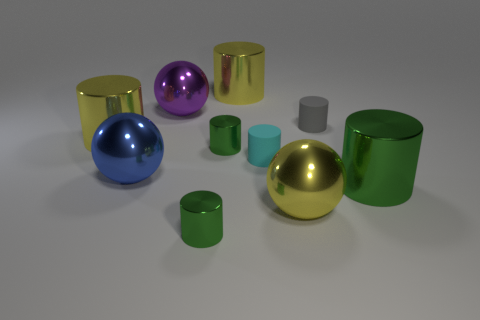Subtract all gray balls. Subtract all purple blocks. How many balls are left? 3 Subtract all purple blocks. How many cyan spheres are left? 0 Add 8 small greens. How many large yellows exist? 0 Subtract all large yellow metal spheres. Subtract all purple things. How many objects are left? 8 Add 4 big yellow metallic balls. How many big yellow metallic balls are left? 5 Add 6 blue cylinders. How many blue cylinders exist? 6 Subtract all yellow cylinders. How many cylinders are left? 5 Subtract all small cyan rubber cylinders. How many cylinders are left? 6 Subtract 0 brown balls. How many objects are left? 10 How many green cylinders must be subtracted to get 1 green cylinders? 2 